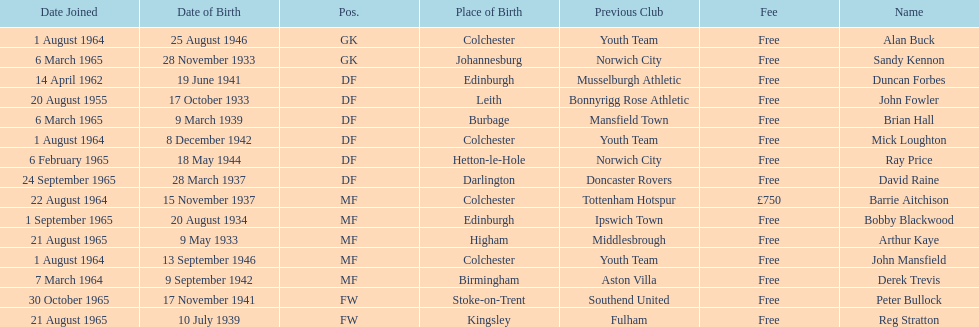How many players are listed as df? 6. Parse the table in full. {'header': ['Date Joined', 'Date of Birth', 'Pos.', 'Place of Birth', 'Previous Club', 'Fee', 'Name'], 'rows': [['1 August 1964', '25 August 1946', 'GK', 'Colchester', 'Youth Team', 'Free', 'Alan Buck'], ['6 March 1965', '28 November 1933', 'GK', 'Johannesburg', 'Norwich City', 'Free', 'Sandy Kennon'], ['14 April 1962', '19 June 1941', 'DF', 'Edinburgh', 'Musselburgh Athletic', 'Free', 'Duncan Forbes'], ['20 August 1955', '17 October 1933', 'DF', 'Leith', 'Bonnyrigg Rose Athletic', 'Free', 'John Fowler'], ['6 March 1965', '9 March 1939', 'DF', 'Burbage', 'Mansfield Town', 'Free', 'Brian Hall'], ['1 August 1964', '8 December 1942', 'DF', 'Colchester', 'Youth Team', 'Free', 'Mick Loughton'], ['6 February 1965', '18 May 1944', 'DF', 'Hetton-le-Hole', 'Norwich City', 'Free', 'Ray Price'], ['24 September 1965', '28 March 1937', 'DF', 'Darlington', 'Doncaster Rovers', 'Free', 'David Raine'], ['22 August 1964', '15 November 1937', 'MF', 'Colchester', 'Tottenham Hotspur', '£750', 'Barrie Aitchison'], ['1 September 1965', '20 August 1934', 'MF', 'Edinburgh', 'Ipswich Town', 'Free', 'Bobby Blackwood'], ['21 August 1965', '9 May 1933', 'MF', 'Higham', 'Middlesbrough', 'Free', 'Arthur Kaye'], ['1 August 1964', '13 September 1946', 'MF', 'Colchester', 'Youth Team', 'Free', 'John Mansfield'], ['7 March 1964', '9 September 1942', 'MF', 'Birmingham', 'Aston Villa', 'Free', 'Derek Trevis'], ['30 October 1965', '17 November 1941', 'FW', 'Stoke-on-Trent', 'Southend United', 'Free', 'Peter Bullock'], ['21 August 1965', '10 July 1939', 'FW', 'Kingsley', 'Fulham', 'Free', 'Reg Stratton']]} 